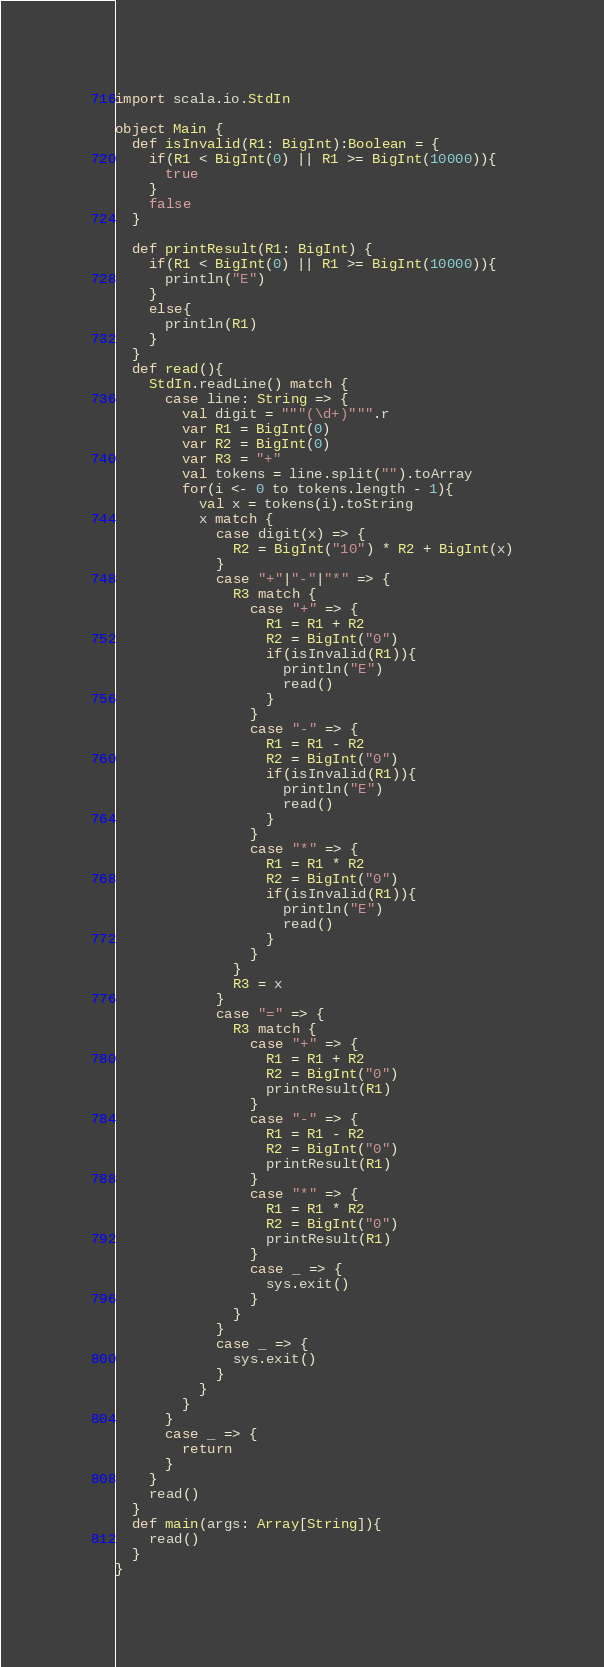<code> <loc_0><loc_0><loc_500><loc_500><_Scala_>import scala.io.StdIn

object Main {
  def isInvalid(R1: BigInt):Boolean = {
    if(R1 < BigInt(0) || R1 >= BigInt(10000)){
      true
    }
    false
  }

  def printResult(R1: BigInt) {
    if(R1 < BigInt(0) || R1 >= BigInt(10000)){
      println("E")
    }
    else{
      println(R1)
    }
  }
  def read(){
    StdIn.readLine() match {
      case line: String => {
        val digit = """(\d+)""".r
        var R1 = BigInt(0)
        var R2 = BigInt(0)
        var R3 = "+"
        val tokens = line.split("").toArray
        for(i <- 0 to tokens.length - 1){
          val x = tokens(i).toString
          x match {
            case digit(x) => {
              R2 = BigInt("10") * R2 + BigInt(x)
            }
            case "+"|"-"|"*" => {
              R3 match {
                case "+" => {
                  R1 = R1 + R2
                  R2 = BigInt("0")
                  if(isInvalid(R1)){
                    println("E")
                    read()
                  }
                }
                case "-" => {
                  R1 = R1 - R2
                  R2 = BigInt("0")
                  if(isInvalid(R1)){
                    println("E")
                    read()
                  }
                }
                case "*" => {
                  R1 = R1 * R2
                  R2 = BigInt("0")
                  if(isInvalid(R1)){
                    println("E")
                    read()
                  }
                }
              }
              R3 = x
            }
            case "=" => {
              R3 match {
                case "+" => {
                  R1 = R1 + R2
                  R2 = BigInt("0")
                  printResult(R1)
                }
                case "-" => {
                  R1 = R1 - R2
                  R2 = BigInt("0")
                  printResult(R1)
                }
                case "*" => {
                  R1 = R1 * R2
                  R2 = BigInt("0")
                  printResult(R1)
                }
                case _ => {
                  sys.exit()
                }
              }
            }
            case _ => {
              sys.exit()
            }
          }
        }
      }
      case _ => {
        return
      }
    }
    read()
  }
  def main(args: Array[String]){
    read()
  }
}</code> 